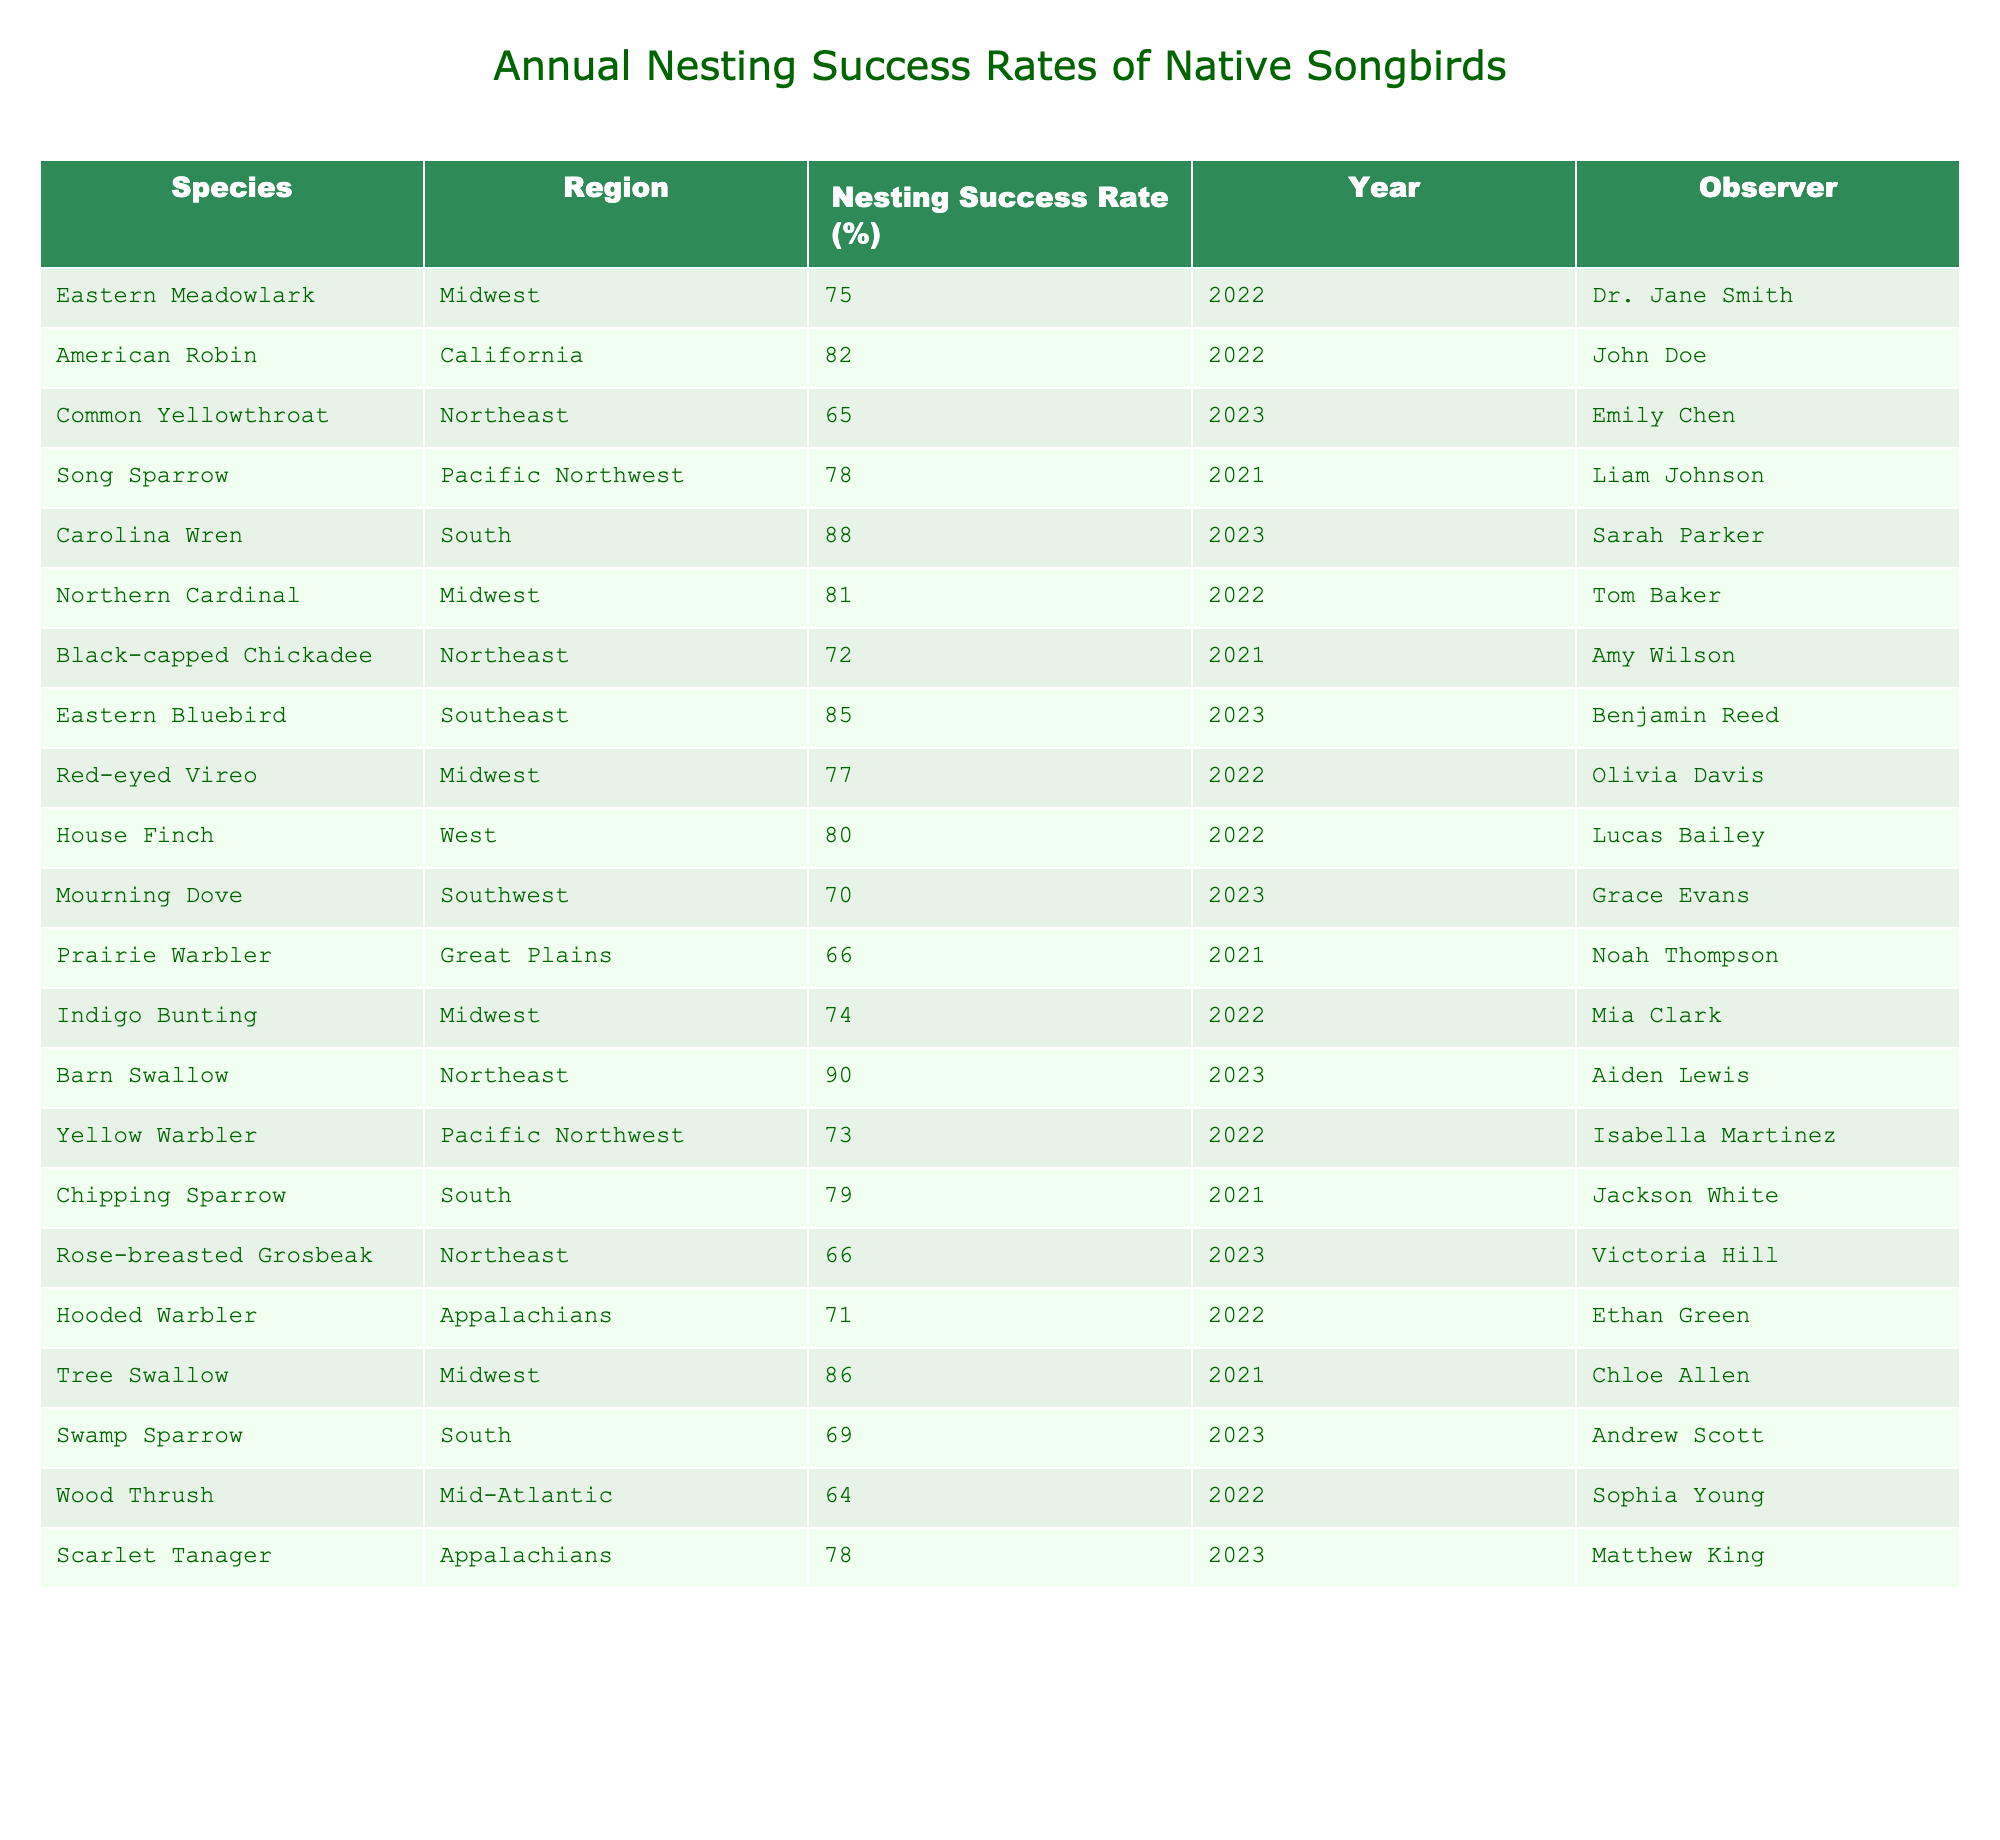What is the nesting success rate of the Eastern Meadowlark? The table shows that the nesting success rate for the Eastern Meadowlark is 75%.
Answer: 75% Which species had the highest nesting success rate in 2023? Looking at the data for 2023, the Barn Swallow had the highest nesting success rate at 90%.
Answer: 90% How many species had a nesting success rate above 80% in the table? The species with nesting success rates above 80% are the American Robin (82%), Carolina Wren (88%), Eastern Bluebird (85%), and Barn Swallow (90%). That makes a total of 4 species.
Answer: 4 What is the average nesting success rate for species observed in the Midwest? The nesting success rates for the Midwest species are 75%, 81%, 77%, 74%, and 86%. The average is (75 + 81 + 77 + 74 + 86) / 5 = 78.6%.
Answer: 78.6% Is the nesting success rate of the Red-eyed Vireo higher than that of the Black-capped Chickadee? The nesting success rate for the Red-eyed Vireo is 77%, while the Black-capped Chickadee has a rate of 72%. Since 77% is greater than 72%, the statement is true.
Answer: Yes Which region has the lowest average nesting success rate based on the provided species? The regions and their respective rates are the Midwest (78.6%), California (82%), Northeast (73.4%), South (78.75%), Pacific Northwest (75.5%), Southwest (70%), Great Plains (66%), and Appalachians (74.5%). The Great Plains has the lowest average at 66%.
Answer: Great Plains How does the nesting success rate of the House Finch compare to that of the Yellow Warbler? The House Finch has a nesting success rate of 80%, while the Yellow Warbler's rate is 73%. Since 80% is higher than 73%, House Finch has a better rate than the Yellow Warbler.
Answer: Higher What is the difference in nesting success rates between the Mourning Dove and the Prairie Warbler? The Mourning Dove has a rate of 70%, and the Prairie Warbler has a rate of 66%. The difference is 70 - 66 = 4%.
Answer: 4% Which observer reported the nesting success rate of the Scarlet Tanager? The table indicates that the Scarlet Tanager's nesting success rate was reported by Matthew King.
Answer: Matthew King In which year did the Eastern Bluebird have a nesting success rate of 85%? According to the table, the Eastern Bluebird had a nesting success rate of 85% in the year 2023.
Answer: 2023 